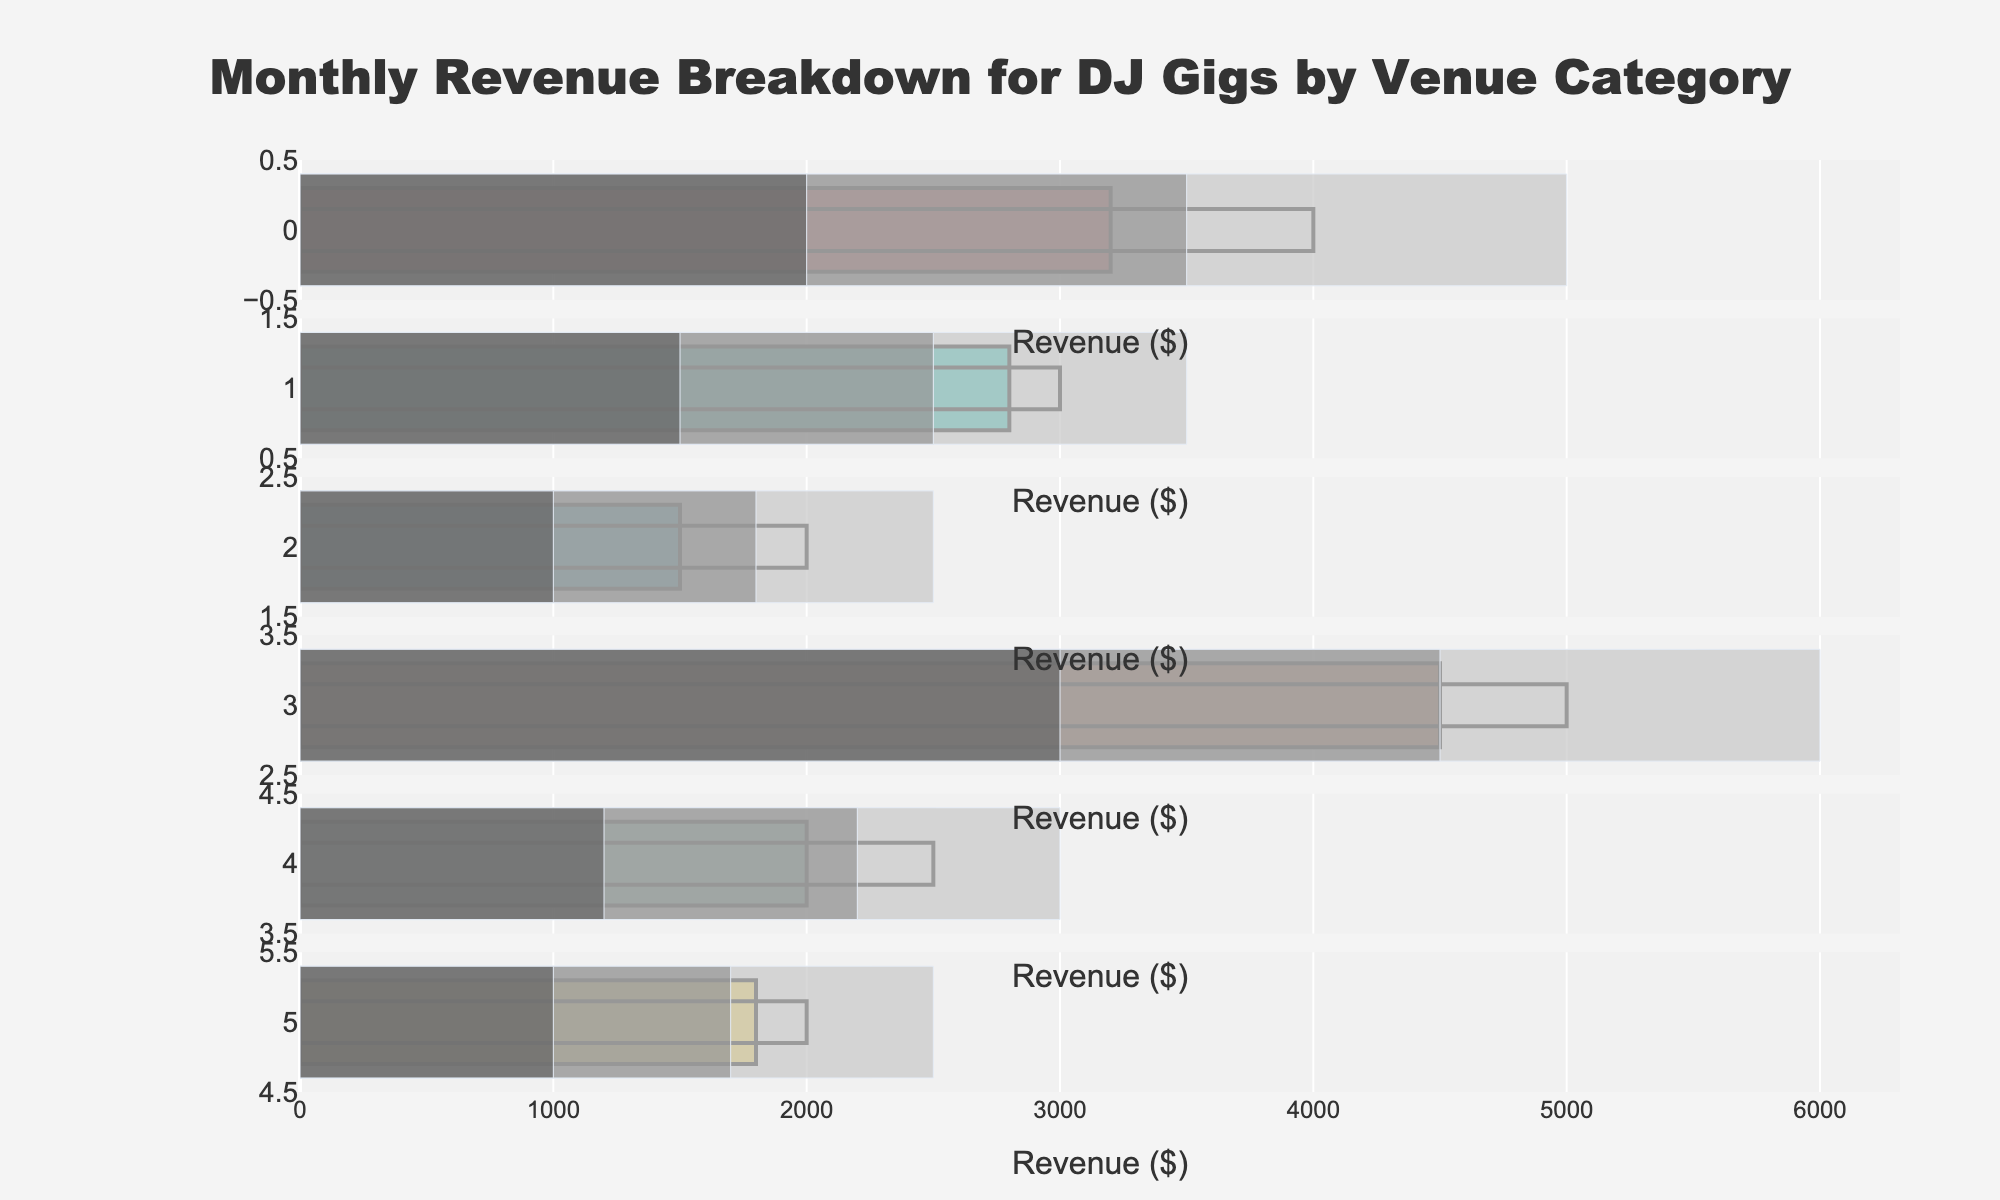What is the title of the chart? The title of the chart is displayed at the top center of the figure. It reads "Monthly Revenue Breakdown for DJ Gigs by Venue Category" in bold text.
Answer: Monthly Revenue Breakdown for DJ Gigs by Venue Category Which venue category has the highest actual revenue? By looking at the lengths of the main bars in each category, the longest bar represents the venue category with the highest revenue. The Music Festivals category has the highest actual revenue.
Answer: Music Festivals What is the color of the bars representing the actual revenue for each category? Each category has a uniquely colored bar representing the actual revenue. The colors are listed as follows: Nightclubs - red, Weddings - teal, Corporate Events - blue, Music Festivals - salmon, Private Parties - light green, College Campuses - yellow.
Answer: Various colors (red, teal, blue, salmon, light green, yellow) How many venue categories have actual revenue less than their target revenue? We compare the actual revenue bars with the target markers. Categories with shorter bars than their respective target markers are Nightclubs, Weddings, Corporate Events, Private Parties, and College Campuses.
Answer: 5 For which venue category is the actual revenue closest to the target revenue? The actual revenue of Weddings is closest to its target, with only a small difference between the bar and the target marker.
Answer: Weddings What is the range for "good performance" in the Music Festivals category? The range for "good performance" is indicated by the middle shaded bar. For Music Festivals, this range is from 3000 to 4500 dollars.
Answer: 3000 to 4500 dollars Which category has the smallest gap between the actual revenue and the "good performance" minimum? The actual revenue bars and the bottom boundary of the "good performance" range can be compared. For College Campuses, the gap is smallest, with actual revenue at 1800 and the good performance starting at 1700.
Answer: College Campuses What is the total actual revenue across all categories? Sum up all actual revenue values: 3200 (Nightclubs) + 2800 (Weddings) + 1500 (Corporate Events) + 4500 (Music Festivals) + 2000 (Private Parties) + 1800 (College Campuses). This totals to 15800.
Answer: 15800 Which categories fall within the "excellent performance" range? Compare actual revenue bars with the highest performance range bars. Only Music Festivals’ actual revenue meets its "excellent performance" criteria of hitting 5000 dollars.
Answer: Music Festivals 